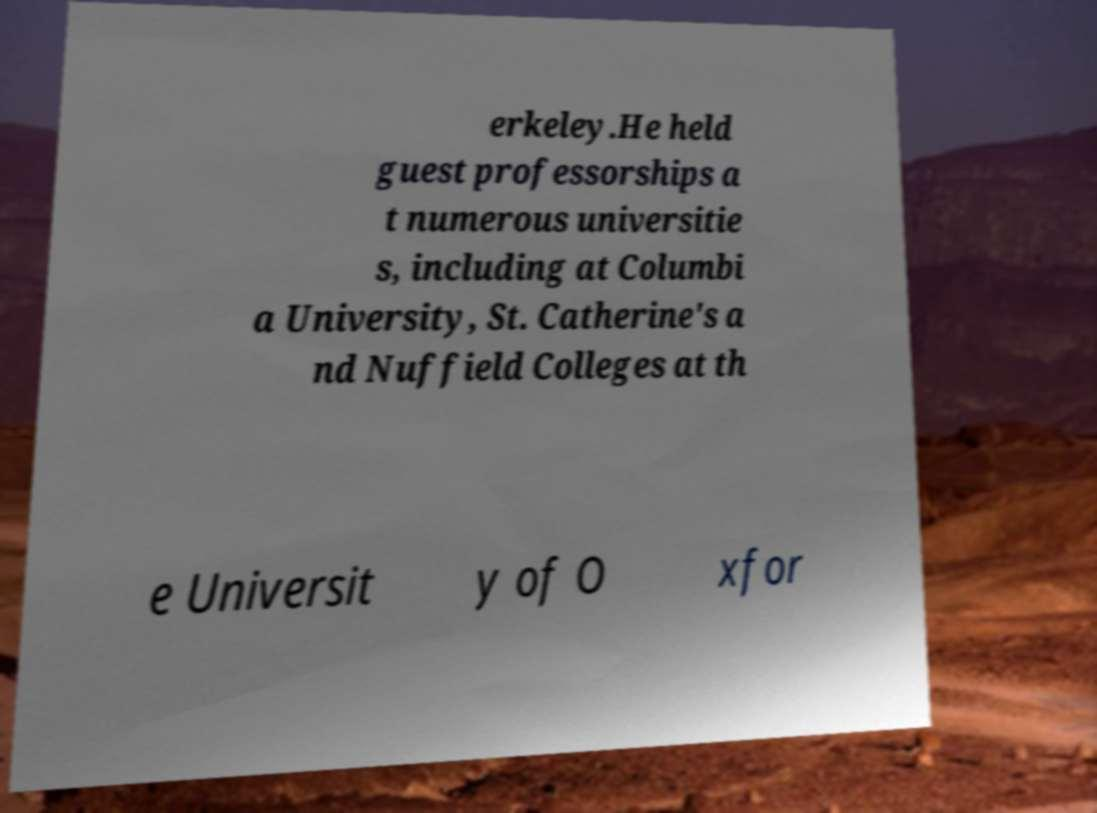Can you read and provide the text displayed in the image?This photo seems to have some interesting text. Can you extract and type it out for me? erkeley.He held guest professorships a t numerous universitie s, including at Columbi a University, St. Catherine's a nd Nuffield Colleges at th e Universit y of O xfor 